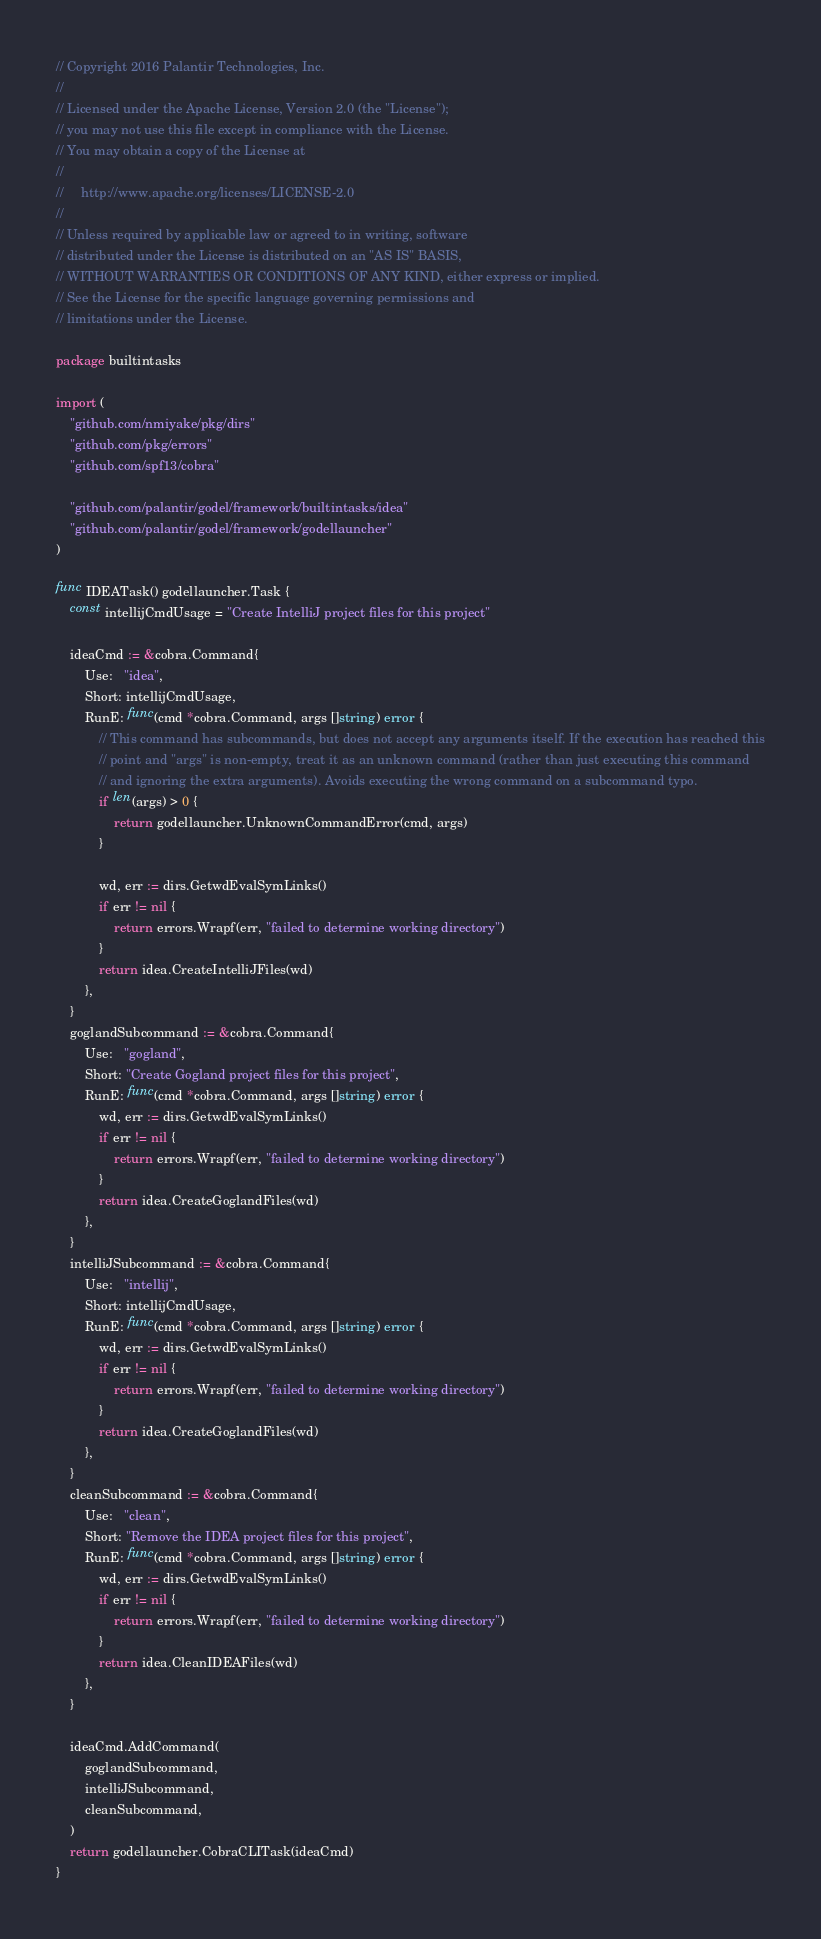<code> <loc_0><loc_0><loc_500><loc_500><_Go_>// Copyright 2016 Palantir Technologies, Inc.
//
// Licensed under the Apache License, Version 2.0 (the "License");
// you may not use this file except in compliance with the License.
// You may obtain a copy of the License at
//
//     http://www.apache.org/licenses/LICENSE-2.0
//
// Unless required by applicable law or agreed to in writing, software
// distributed under the License is distributed on an "AS IS" BASIS,
// WITHOUT WARRANTIES OR CONDITIONS OF ANY KIND, either express or implied.
// See the License for the specific language governing permissions and
// limitations under the License.

package builtintasks

import (
	"github.com/nmiyake/pkg/dirs"
	"github.com/pkg/errors"
	"github.com/spf13/cobra"

	"github.com/palantir/godel/framework/builtintasks/idea"
	"github.com/palantir/godel/framework/godellauncher"
)

func IDEATask() godellauncher.Task {
	const intellijCmdUsage = "Create IntelliJ project files for this project"

	ideaCmd := &cobra.Command{
		Use:   "idea",
		Short: intellijCmdUsage,
		RunE: func(cmd *cobra.Command, args []string) error {
			// This command has subcommands, but does not accept any arguments itself. If the execution has reached this
			// point and "args" is non-empty, treat it as an unknown command (rather than just executing this command
			// and ignoring the extra arguments). Avoids executing the wrong command on a subcommand typo.
			if len(args) > 0 {
				return godellauncher.UnknownCommandError(cmd, args)
			}

			wd, err := dirs.GetwdEvalSymLinks()
			if err != nil {
				return errors.Wrapf(err, "failed to determine working directory")
			}
			return idea.CreateIntelliJFiles(wd)
		},
	}
	goglandSubcommand := &cobra.Command{
		Use:   "gogland",
		Short: "Create Gogland project files for this project",
		RunE: func(cmd *cobra.Command, args []string) error {
			wd, err := dirs.GetwdEvalSymLinks()
			if err != nil {
				return errors.Wrapf(err, "failed to determine working directory")
			}
			return idea.CreateGoglandFiles(wd)
		},
	}
	intelliJSubcommand := &cobra.Command{
		Use:   "intellij",
		Short: intellijCmdUsage,
		RunE: func(cmd *cobra.Command, args []string) error {
			wd, err := dirs.GetwdEvalSymLinks()
			if err != nil {
				return errors.Wrapf(err, "failed to determine working directory")
			}
			return idea.CreateGoglandFiles(wd)
		},
	}
	cleanSubcommand := &cobra.Command{
		Use:   "clean",
		Short: "Remove the IDEA project files for this project",
		RunE: func(cmd *cobra.Command, args []string) error {
			wd, err := dirs.GetwdEvalSymLinks()
			if err != nil {
				return errors.Wrapf(err, "failed to determine working directory")
			}
			return idea.CleanIDEAFiles(wd)
		},
	}

	ideaCmd.AddCommand(
		goglandSubcommand,
		intelliJSubcommand,
		cleanSubcommand,
	)
	return godellauncher.CobraCLITask(ideaCmd)
}
</code> 